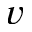<formula> <loc_0><loc_0><loc_500><loc_500>v</formula> 